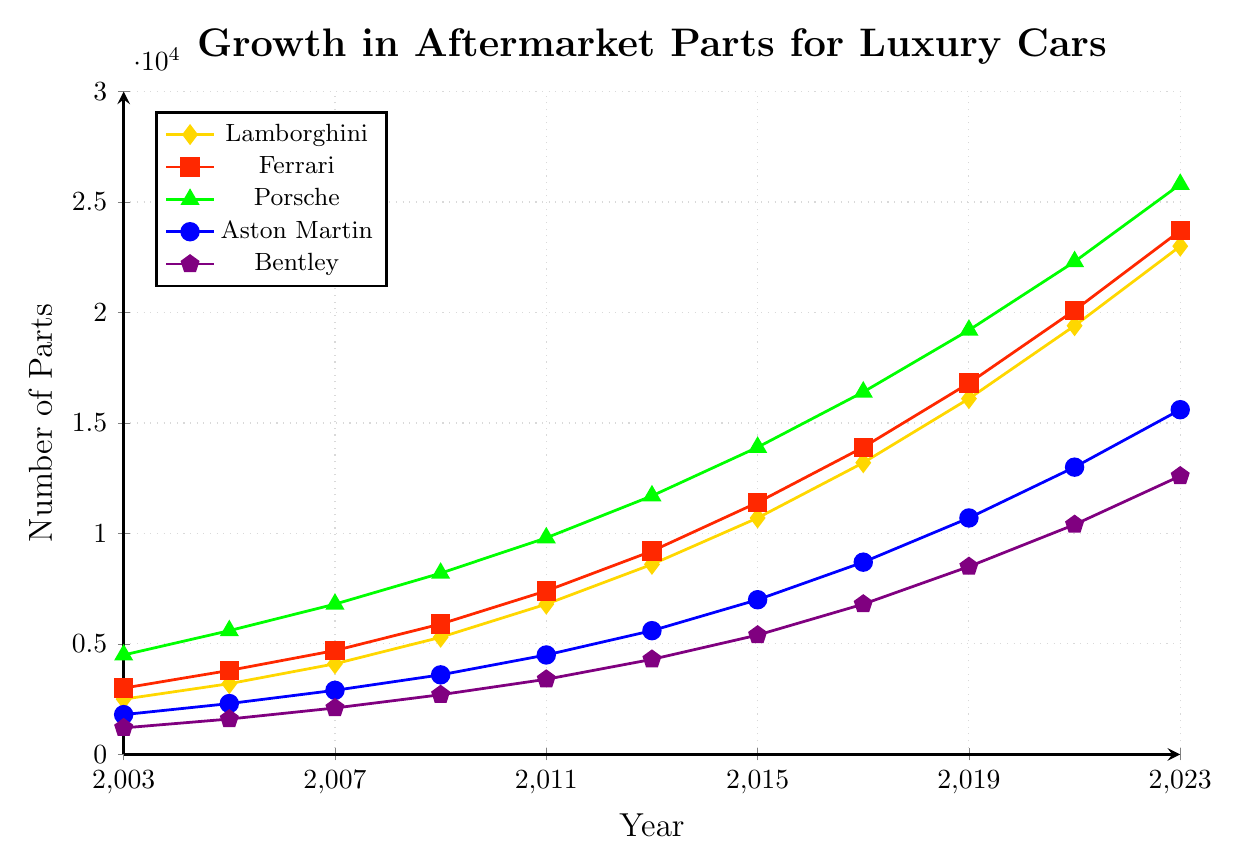Which luxury car brand had the highest number of aftermarket parts available in 2023? To determine this, look at the value for each brand in 2023. Porsche has the maximum value at 25800.
Answer: Porsche How many more aftermarket parts were available for Ferrari in 2023 compared to 2003? Subtract the number of parts for Ferrari in 2003 from the number of parts in 2023: 23700 - 3000 = 20700.
Answer: 20700 Which year saw the fastest growth in aftermarket parts for Lamborghini between 2017 and 2021? Calculate the yearly increments: between 2017 and 2019, it's 16100 - 13200 = 2900, and between 2019 and 2021, it's 19400 - 16100 = 3300. Thus, the fastest growth was between 2019 and 2021.
Answer: 2019 to 2021 What is the average number of aftermarket parts available in 2023 across all brands? Sum the values of all brands for 2023 and divide by the number of brands: (23000 + 23700 + 25800 + 15600 + 12600) / 5 = 20140.
Answer: 20140 Which brand had the least number of aftermarket parts available in 2013, and what was that number? Find the smallest value in 2013: Bentley had the least number with 4300 parts.
Answer: Bentley, 4300 In which year did the number of aftermarket parts for Aston Martin first exceed 10,000? Look for the year when Aston Martin's value surpasses 10,000 for the first time: in 2019 with 10700.
Answer: 2019 Compare the growth in aftermarket parts for Bentley between 2003 and 2023 to that of Porsche. Which brand had a higher absolute increase? Find the difference between 2023 and 2003 for both brands: Bentley (12600 - 1200 = 11400), Porsche (25800 - 4500 = 21300). Porsche had a higher increase.
Answer: Porsche What is the combined number of aftermarket parts available for all brands in 2009? Sum the values for all brands in 2009: 5300 + 5900 + 8200 + 3600 + 2700 = 25700.
Answer: 25700 